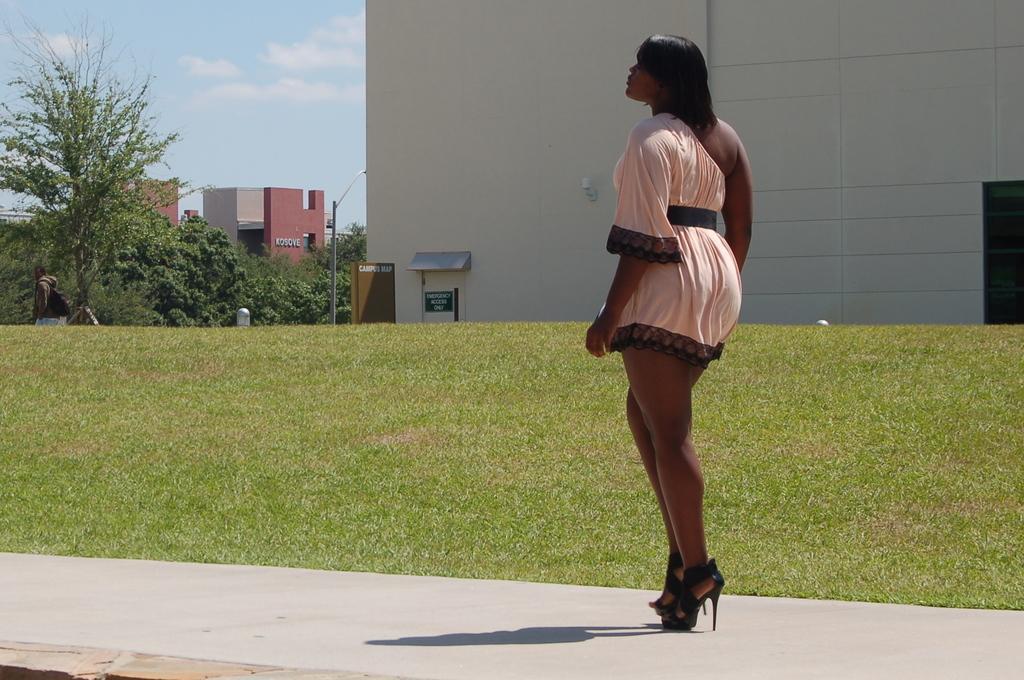Could you give a brief overview of what you see in this image? As we can see in the image there is grass, trees, buildings, a woman wearing pink color dress and on the top there is sky. 